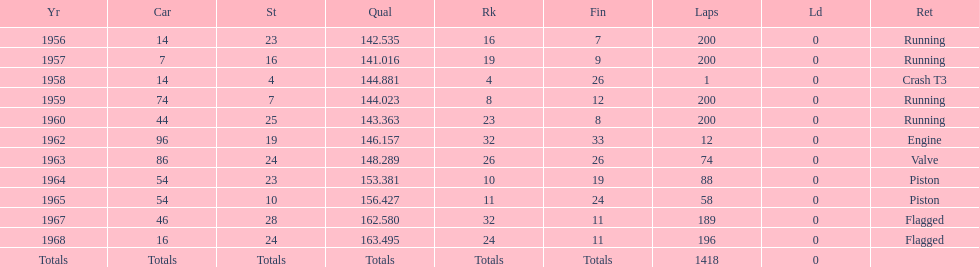Which year is the last qual on the chart 1968. 